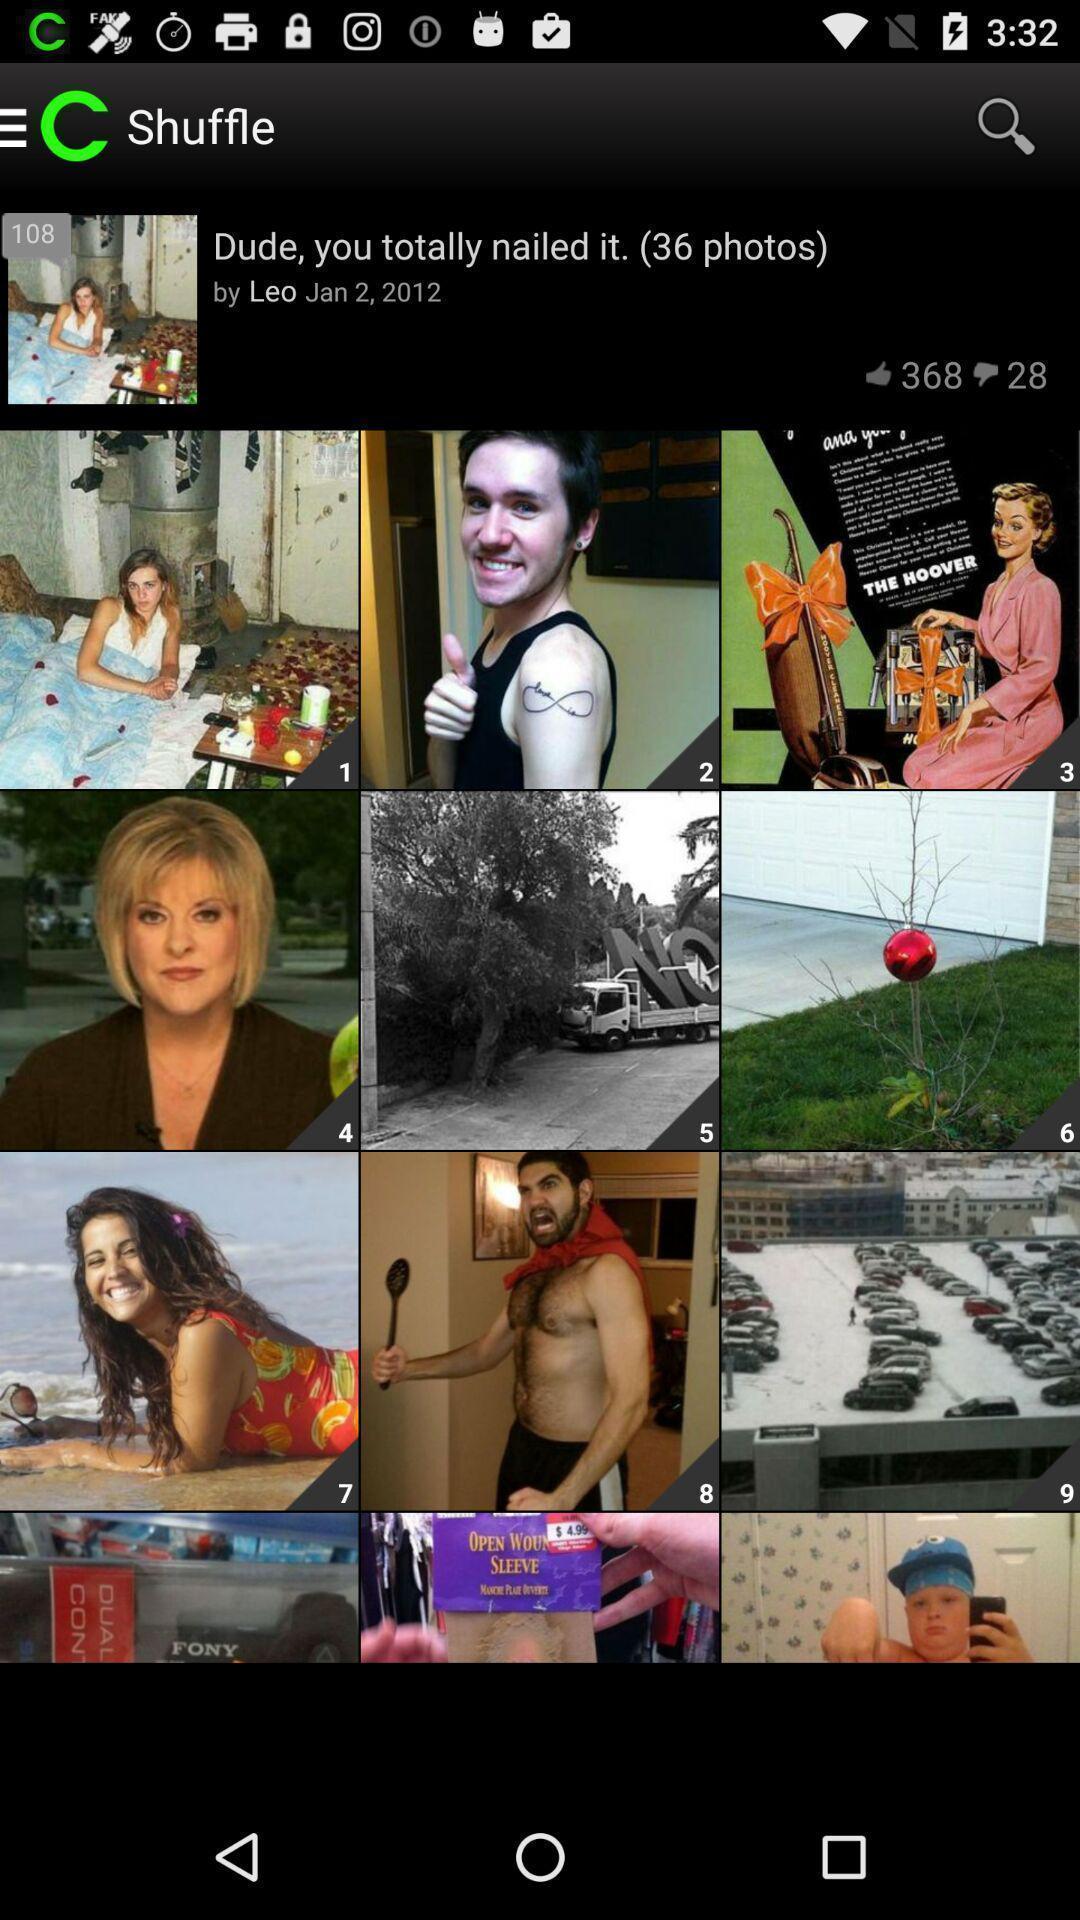Describe the content in this image. Screen shows to shuffle photos. 